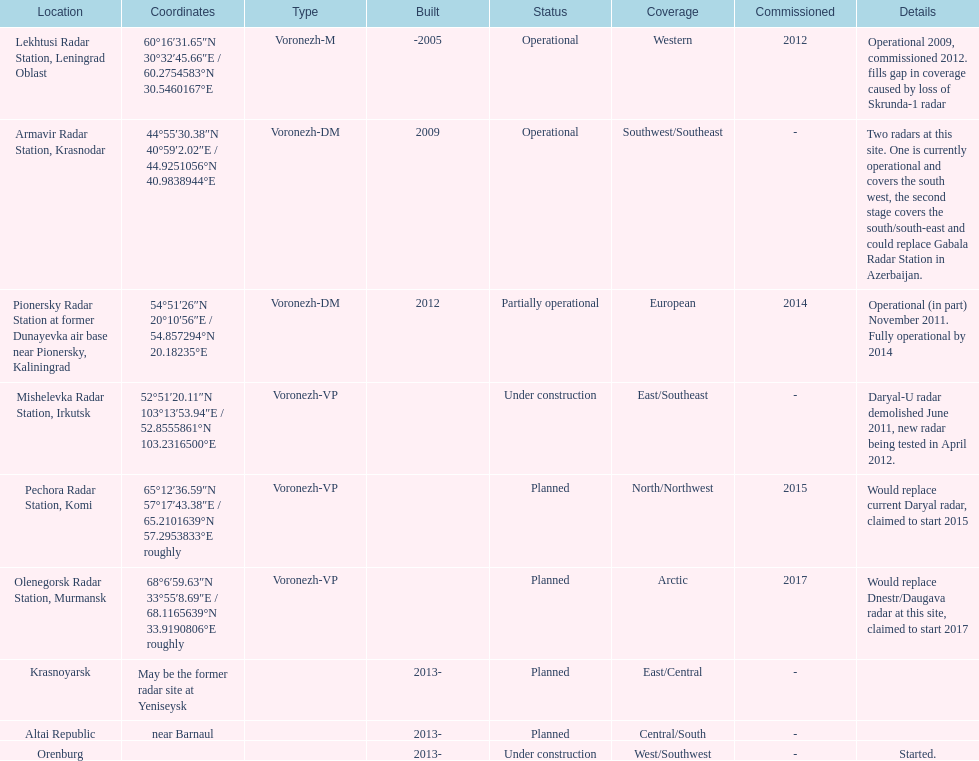What is the only radar that will start in 2015? Pechora Radar Station, Komi. 